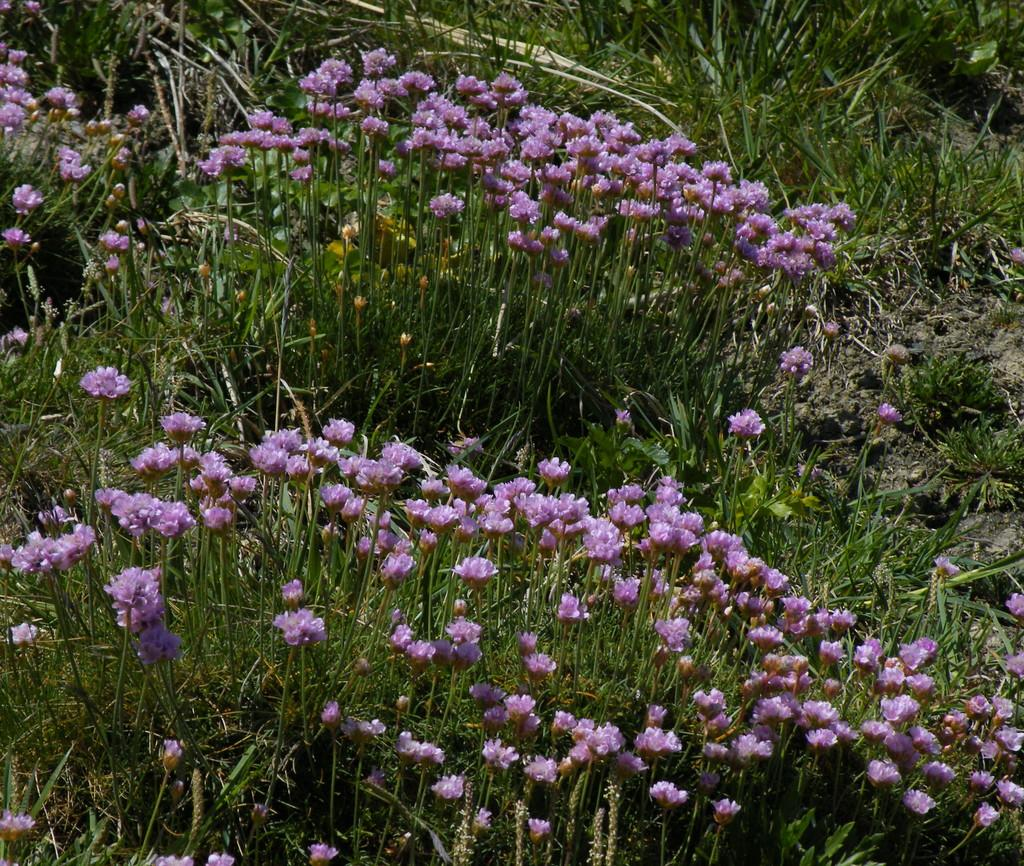What type of living organisms can be seen in the image? Flower plants can be seen in the image. What type of pencil can be seen being used to draw the flowers in the image? There is no pencil present in the image, nor is there any indication that the flowers are being drawn. 